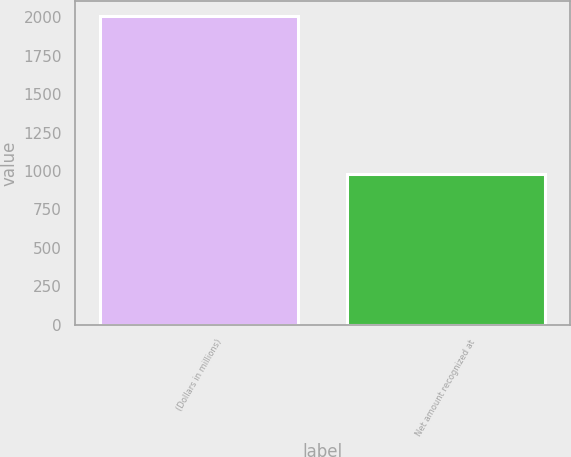<chart> <loc_0><loc_0><loc_500><loc_500><bar_chart><fcel>(Dollars in millions)<fcel>Net amount recognized at<nl><fcel>2005<fcel>981<nl></chart> 